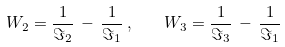<formula> <loc_0><loc_0><loc_500><loc_500>W _ { 2 } = \frac { 1 } { \Im _ { 2 } } \, - \, \frac { 1 } { \Im _ { 1 } } \, , \quad W _ { 3 } = \frac { 1 } { \Im _ { 3 } } \, - \, \frac { 1 } { \Im _ { 1 } }</formula> 